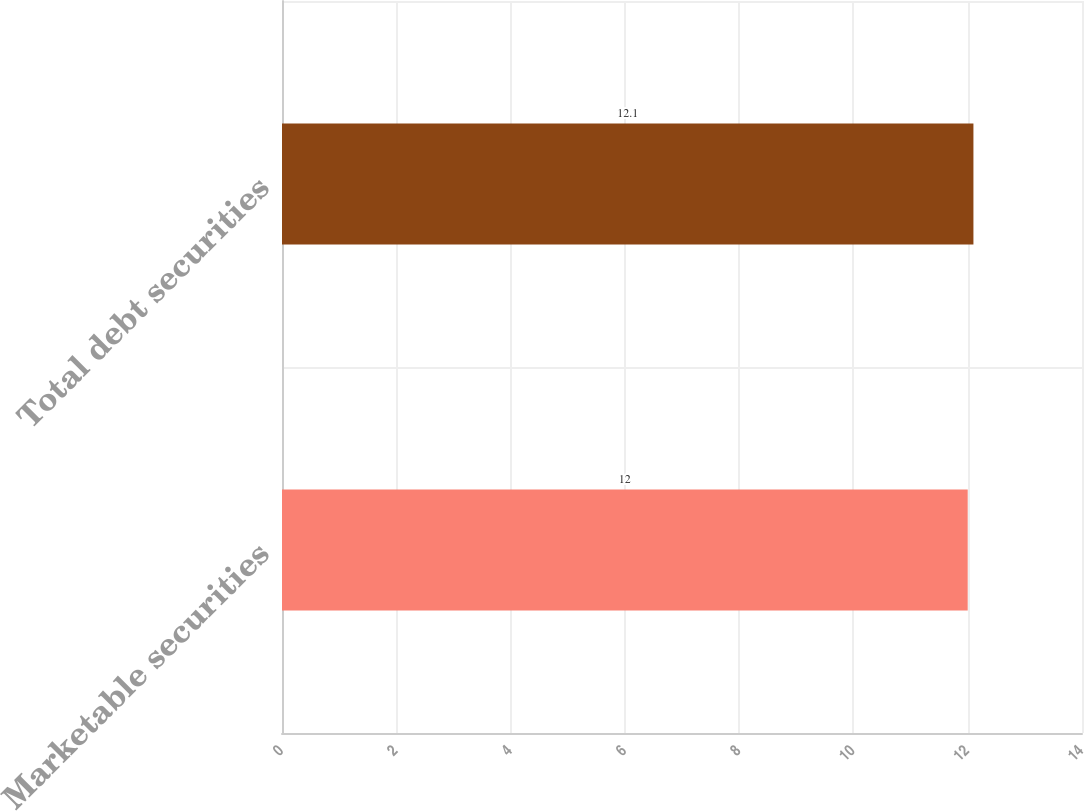Convert chart to OTSL. <chart><loc_0><loc_0><loc_500><loc_500><bar_chart><fcel>Marketable securities<fcel>Total debt securities<nl><fcel>12<fcel>12.1<nl></chart> 